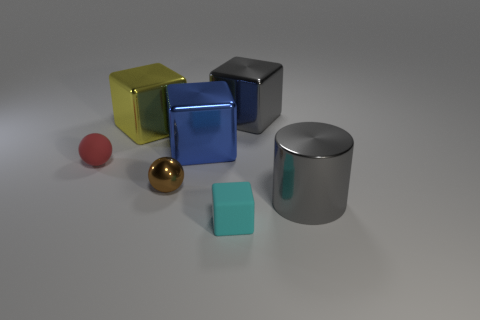What is the size of the matte object that is on the left side of the small cyan matte cube?
Offer a very short reply. Small. Is the number of red matte things less than the number of tiny red shiny things?
Your response must be concise. No. Is the gray thing that is in front of the large gray metallic cube made of the same material as the yellow block that is behind the cyan block?
Your answer should be compact. Yes. What is the shape of the large thing in front of the tiny matte object that is behind the gray thing in front of the big gray block?
Keep it short and to the point. Cylinder. How many blue objects are made of the same material as the big yellow object?
Offer a very short reply. 1. What number of objects are in front of the large thing that is left of the metallic sphere?
Keep it short and to the point. 5. There is a big thing on the left side of the blue block; is its color the same as the object that is in front of the cylinder?
Your answer should be very brief. No. What is the shape of the thing that is both in front of the tiny metallic sphere and behind the cyan cube?
Keep it short and to the point. Cylinder. Is there a large cyan shiny thing that has the same shape as the cyan matte object?
Offer a very short reply. No. What is the shape of the blue metallic thing that is the same size as the yellow shiny block?
Provide a succinct answer. Cube. 